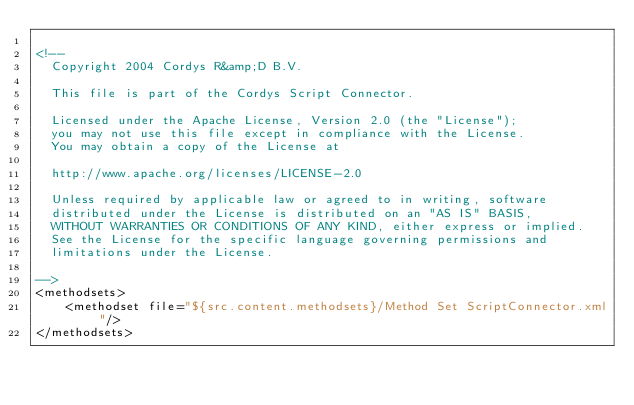<code> <loc_0><loc_0><loc_500><loc_500><_XML_>
<!--
  Copyright 2004 Cordys R&amp;D B.V. 
 
  This file is part of the Cordys Script Connector. 
 
  Licensed under the Apache License, Version 2.0 (the "License");
  you may not use this file except in compliance with the License.
  You may obtain a copy of the License at
  
  http://www.apache.org/licenses/LICENSE-2.0
  
  Unless required by applicable law or agreed to in writing, software
  distributed under the License is distributed on an "AS IS" BASIS,
  WITHOUT WARRANTIES OR CONDITIONS OF ANY KIND, either express or implied.
  See the License for the specific language governing permissions and
  limitations under the License.

-->
<methodsets>
    <methodset file="${src.content.methodsets}/Method Set ScriptConnector.xml"/>
</methodsets>
</code> 